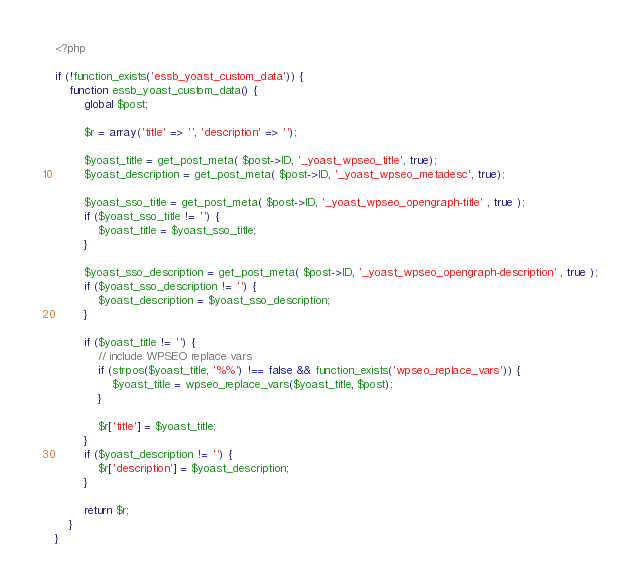<code> <loc_0><loc_0><loc_500><loc_500><_PHP_><?php

if (!function_exists('essb_yoast_custom_data')) {
	function essb_yoast_custom_data() {
		global $post;
		
		$r = array('title' => '', 'description' => '');
		
		$yoast_title = get_post_meta( $post->ID, '_yoast_wpseo_title', true);
		$yoast_description = get_post_meta( $post->ID, '_yoast_wpseo_metadesc', true);
			
		$yoast_sso_title = get_post_meta( $post->ID, '_yoast_wpseo_opengraph-title' , true );
		if ($yoast_sso_title != '') {
			$yoast_title = $yoast_sso_title;
		}
			
		$yoast_sso_description = get_post_meta( $post->ID, '_yoast_wpseo_opengraph-description' , true );
		if ($yoast_sso_description != '') {
			$yoast_description = $yoast_sso_description;
		}
			
		if ($yoast_title != '') {
			// include WPSEO replace vars
			if (strpos($yoast_title, '%%') !== false && function_exists('wpseo_replace_vars')) {
				$yoast_title = wpseo_replace_vars($yoast_title, $post);
			}
		
			$r['title'] = $yoast_title;
		}
		if ($yoast_description != '') {
			$r['description'] = $yoast_description;
		}
		
		return $r;
	}
}</code> 